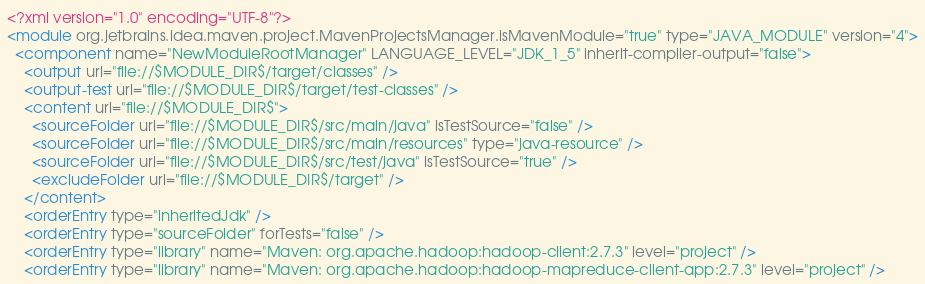<code> <loc_0><loc_0><loc_500><loc_500><_XML_><?xml version="1.0" encoding="UTF-8"?>
<module org.jetbrains.idea.maven.project.MavenProjectsManager.isMavenModule="true" type="JAVA_MODULE" version="4">
  <component name="NewModuleRootManager" LANGUAGE_LEVEL="JDK_1_5" inherit-compiler-output="false">
    <output url="file://$MODULE_DIR$/target/classes" />
    <output-test url="file://$MODULE_DIR$/target/test-classes" />
    <content url="file://$MODULE_DIR$">
      <sourceFolder url="file://$MODULE_DIR$/src/main/java" isTestSource="false" />
      <sourceFolder url="file://$MODULE_DIR$/src/main/resources" type="java-resource" />
      <sourceFolder url="file://$MODULE_DIR$/src/test/java" isTestSource="true" />
      <excludeFolder url="file://$MODULE_DIR$/target" />
    </content>
    <orderEntry type="inheritedJdk" />
    <orderEntry type="sourceFolder" forTests="false" />
    <orderEntry type="library" name="Maven: org.apache.hadoop:hadoop-client:2.7.3" level="project" />
    <orderEntry type="library" name="Maven: org.apache.hadoop:hadoop-mapreduce-client-app:2.7.3" level="project" /></code> 